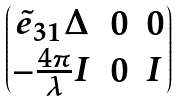<formula> <loc_0><loc_0><loc_500><loc_500>\begin{pmatrix} \tilde { e } _ { 3 1 } \Delta & 0 & 0 \\ - \frac { 4 \pi } { \lambda } I & 0 & I \end{pmatrix}</formula> 